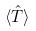Convert formula to latex. <formula><loc_0><loc_0><loc_500><loc_500>\langle \hat { T } \rangle</formula> 